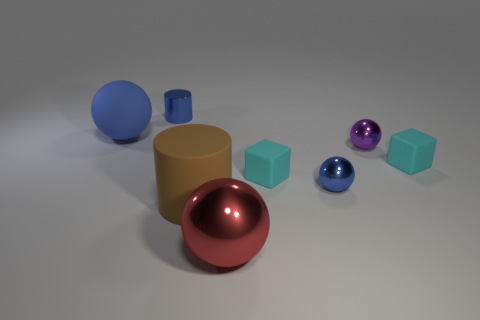Is the number of brown rubber objects to the right of the tiny purple object less than the number of cubes?
Keep it short and to the point. Yes. Is the big red ball made of the same material as the small blue thing to the right of the metal cylinder?
Your response must be concise. Yes. Are there any matte spheres in front of the tiny shiny sphere that is right of the blue object right of the large shiny thing?
Provide a short and direct response. No. There is a tiny cylinder that is the same material as the tiny blue sphere; what is its color?
Your response must be concise. Blue. How big is the rubber thing that is both to the left of the tiny blue sphere and right of the large metallic object?
Offer a very short reply. Small. Is the number of tiny blue cylinders in front of the purple sphere less than the number of cylinders that are behind the blue rubber sphere?
Give a very brief answer. Yes. Do the blue ball behind the purple thing and the blue thing in front of the purple ball have the same material?
Ensure brevity in your answer.  No. There is a small ball that is the same color as the metallic cylinder; what is it made of?
Keep it short and to the point. Metal. What is the shape of the rubber object that is both left of the blue metal ball and to the right of the big matte cylinder?
Offer a very short reply. Cube. What material is the thing behind the large thing to the left of the shiny cylinder?
Offer a terse response. Metal. 